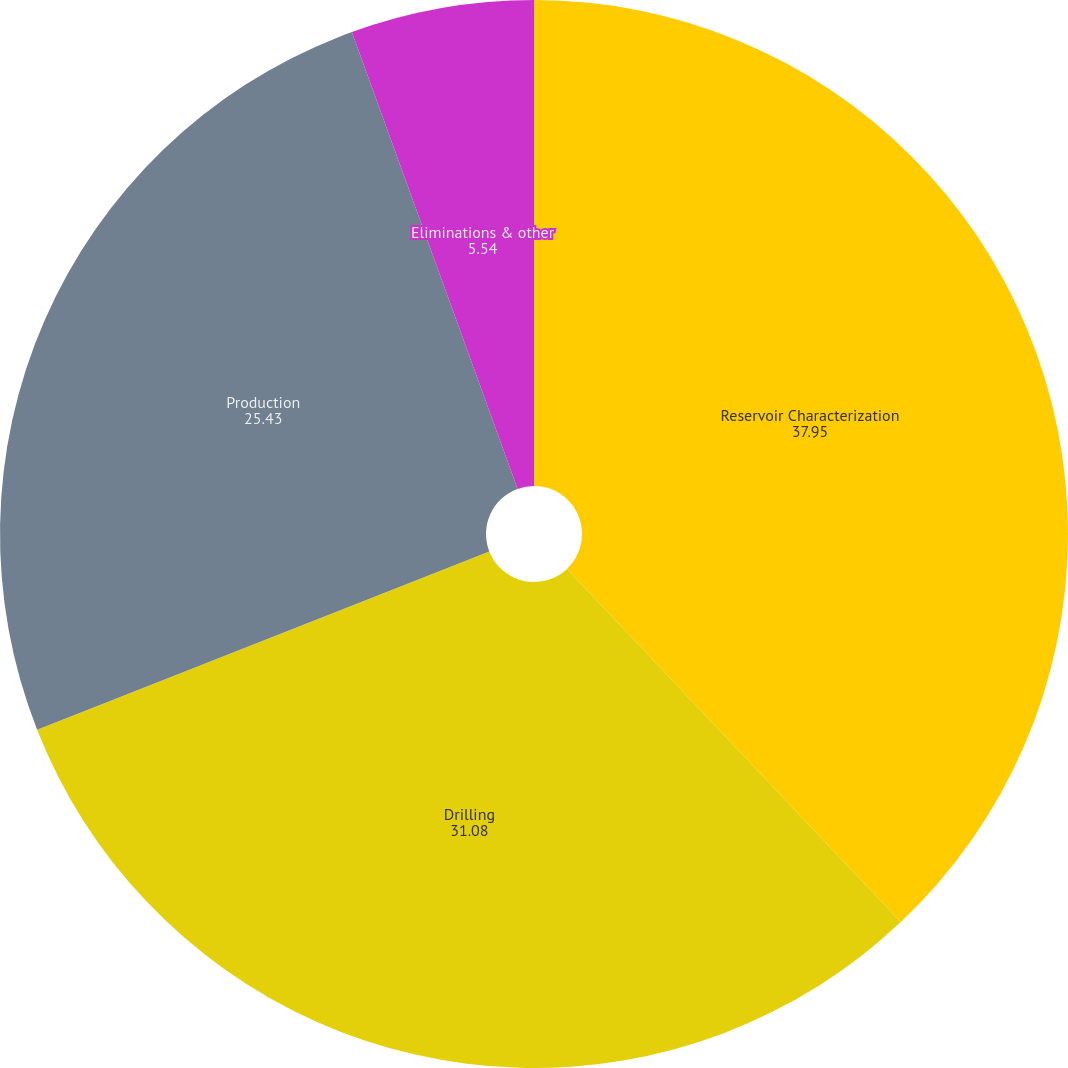Convert chart to OTSL. <chart><loc_0><loc_0><loc_500><loc_500><pie_chart><fcel>Reservoir Characterization<fcel>Drilling<fcel>Production<fcel>Eliminations & other<nl><fcel>37.95%<fcel>31.08%<fcel>25.43%<fcel>5.54%<nl></chart> 